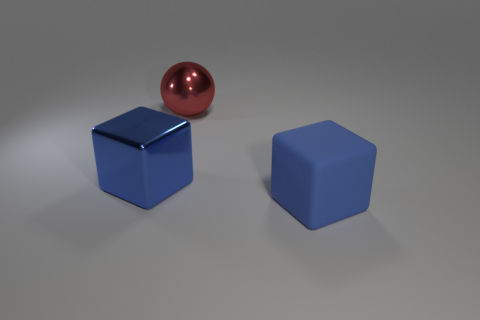Add 1 blue blocks. How many objects exist? 4 Subtract all blocks. How many objects are left? 1 Subtract all big things. Subtract all rubber cylinders. How many objects are left? 0 Add 3 big balls. How many big balls are left? 4 Add 1 big blue rubber things. How many big blue rubber things exist? 2 Subtract 0 purple cylinders. How many objects are left? 3 